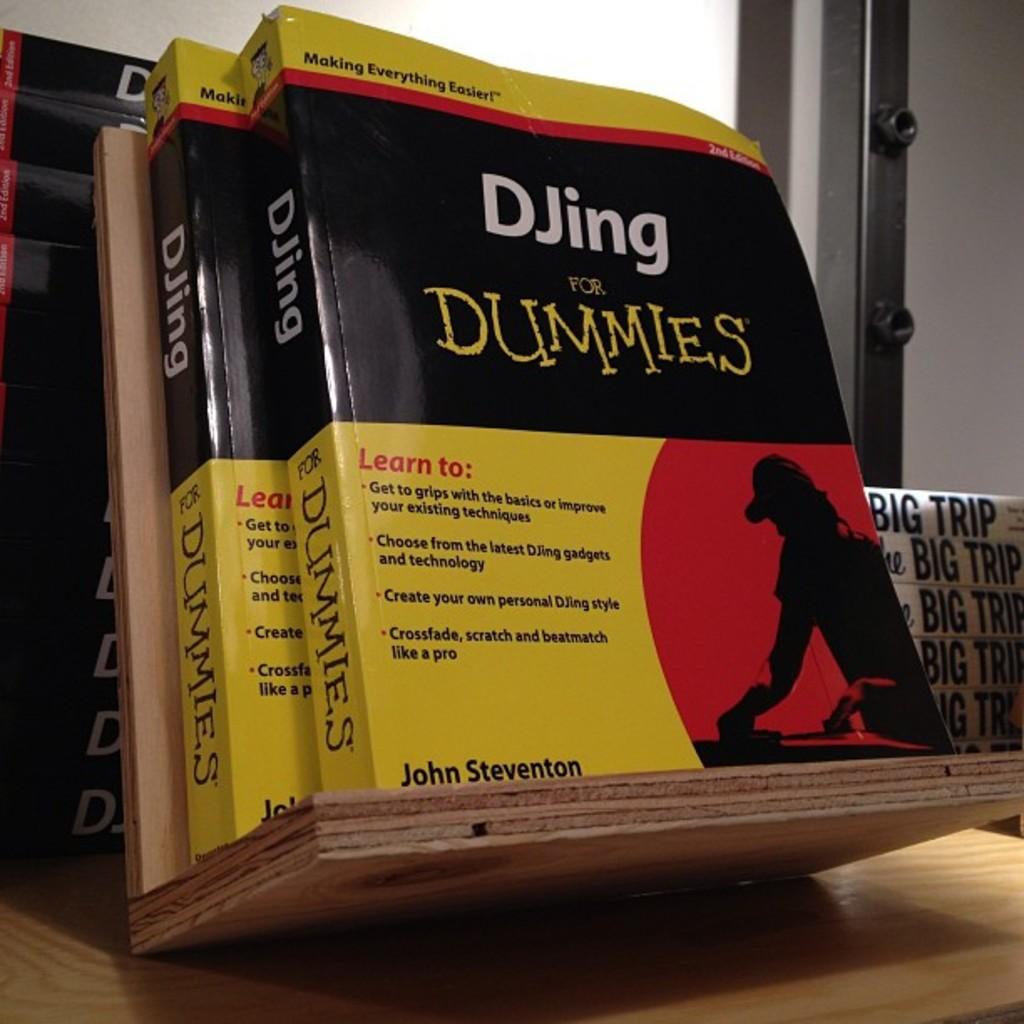Who is the author of the book?
Give a very brief answer. John steventon. 